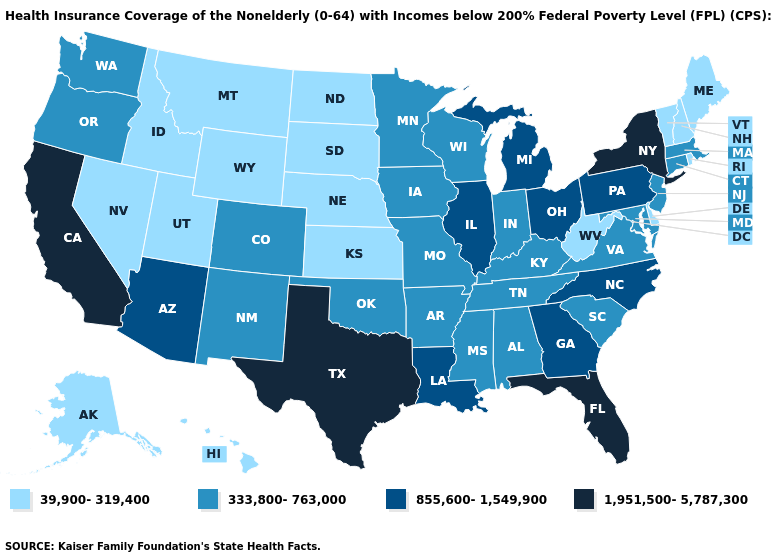What is the value of Rhode Island?
Give a very brief answer. 39,900-319,400. Among the states that border Massachusetts , does New York have the highest value?
Keep it brief. Yes. Name the states that have a value in the range 333,800-763,000?
Concise answer only. Alabama, Arkansas, Colorado, Connecticut, Indiana, Iowa, Kentucky, Maryland, Massachusetts, Minnesota, Mississippi, Missouri, New Jersey, New Mexico, Oklahoma, Oregon, South Carolina, Tennessee, Virginia, Washington, Wisconsin. What is the lowest value in the Northeast?
Quick response, please. 39,900-319,400. What is the value of Maryland?
Write a very short answer. 333,800-763,000. Does Kentucky have the lowest value in the South?
Be succinct. No. Does Iowa have the same value as South Carolina?
Quick response, please. Yes. Name the states that have a value in the range 333,800-763,000?
Keep it brief. Alabama, Arkansas, Colorado, Connecticut, Indiana, Iowa, Kentucky, Maryland, Massachusetts, Minnesota, Mississippi, Missouri, New Jersey, New Mexico, Oklahoma, Oregon, South Carolina, Tennessee, Virginia, Washington, Wisconsin. Name the states that have a value in the range 333,800-763,000?
Give a very brief answer. Alabama, Arkansas, Colorado, Connecticut, Indiana, Iowa, Kentucky, Maryland, Massachusetts, Minnesota, Mississippi, Missouri, New Jersey, New Mexico, Oklahoma, Oregon, South Carolina, Tennessee, Virginia, Washington, Wisconsin. What is the highest value in states that border Nebraska?
Concise answer only. 333,800-763,000. Name the states that have a value in the range 333,800-763,000?
Concise answer only. Alabama, Arkansas, Colorado, Connecticut, Indiana, Iowa, Kentucky, Maryland, Massachusetts, Minnesota, Mississippi, Missouri, New Jersey, New Mexico, Oklahoma, Oregon, South Carolina, Tennessee, Virginia, Washington, Wisconsin. Name the states that have a value in the range 39,900-319,400?
Write a very short answer. Alaska, Delaware, Hawaii, Idaho, Kansas, Maine, Montana, Nebraska, Nevada, New Hampshire, North Dakota, Rhode Island, South Dakota, Utah, Vermont, West Virginia, Wyoming. Does Maryland have the lowest value in the USA?
Be succinct. No. Does Indiana have the highest value in the MidWest?
Write a very short answer. No. Name the states that have a value in the range 39,900-319,400?
Give a very brief answer. Alaska, Delaware, Hawaii, Idaho, Kansas, Maine, Montana, Nebraska, Nevada, New Hampshire, North Dakota, Rhode Island, South Dakota, Utah, Vermont, West Virginia, Wyoming. 